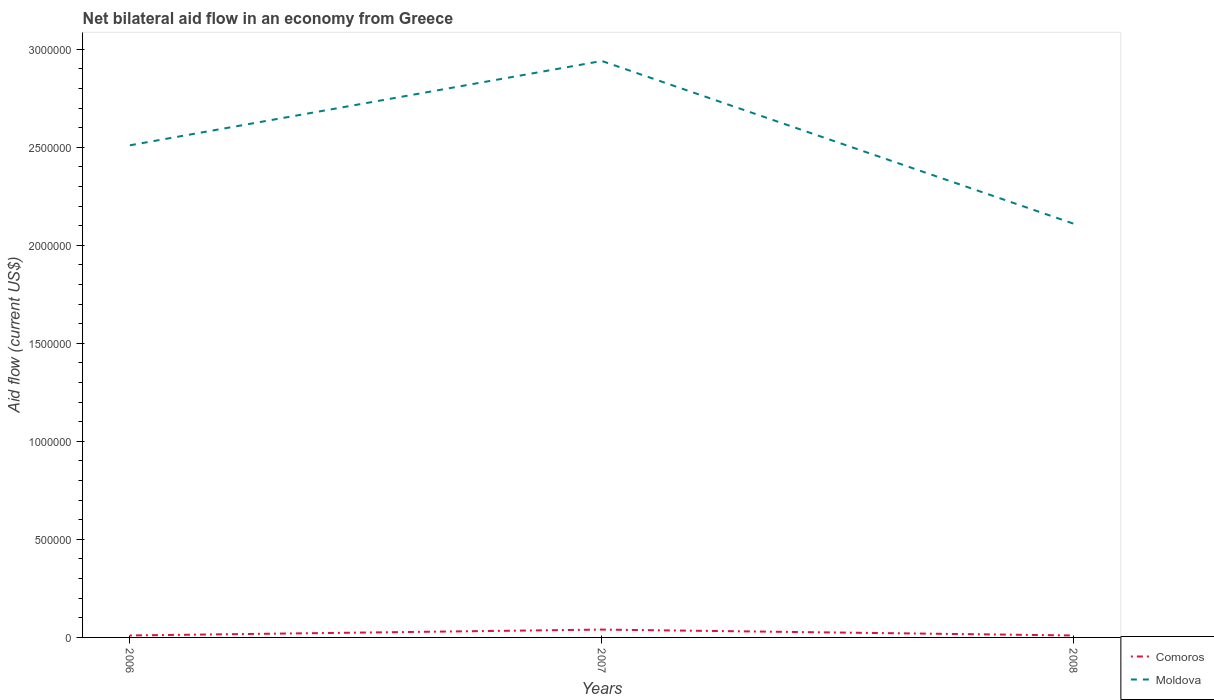How many different coloured lines are there?
Keep it short and to the point. 2. Does the line corresponding to Comoros intersect with the line corresponding to Moldova?
Make the answer very short. No. Is the number of lines equal to the number of legend labels?
Make the answer very short. Yes. Across all years, what is the maximum net bilateral aid flow in Comoros?
Offer a terse response. 10000. What is the total net bilateral aid flow in Moldova in the graph?
Keep it short and to the point. 4.00e+05. What is the difference between the highest and the second highest net bilateral aid flow in Moldova?
Ensure brevity in your answer.  8.30e+05. How many lines are there?
Provide a short and direct response. 2. How many years are there in the graph?
Give a very brief answer. 3. What is the difference between two consecutive major ticks on the Y-axis?
Offer a terse response. 5.00e+05. Does the graph contain grids?
Provide a succinct answer. No. What is the title of the graph?
Provide a short and direct response. Net bilateral aid flow in an economy from Greece. Does "Spain" appear as one of the legend labels in the graph?
Keep it short and to the point. No. What is the label or title of the Y-axis?
Your answer should be compact. Aid flow (current US$). What is the Aid flow (current US$) of Moldova in 2006?
Ensure brevity in your answer.  2.51e+06. What is the Aid flow (current US$) in Moldova in 2007?
Ensure brevity in your answer.  2.94e+06. What is the Aid flow (current US$) of Moldova in 2008?
Your answer should be very brief. 2.11e+06. Across all years, what is the maximum Aid flow (current US$) in Comoros?
Make the answer very short. 4.00e+04. Across all years, what is the maximum Aid flow (current US$) in Moldova?
Offer a terse response. 2.94e+06. Across all years, what is the minimum Aid flow (current US$) in Moldova?
Offer a terse response. 2.11e+06. What is the total Aid flow (current US$) of Comoros in the graph?
Keep it short and to the point. 6.00e+04. What is the total Aid flow (current US$) of Moldova in the graph?
Make the answer very short. 7.56e+06. What is the difference between the Aid flow (current US$) in Comoros in 2006 and that in 2007?
Provide a short and direct response. -3.00e+04. What is the difference between the Aid flow (current US$) in Moldova in 2006 and that in 2007?
Keep it short and to the point. -4.30e+05. What is the difference between the Aid flow (current US$) in Comoros in 2006 and that in 2008?
Your answer should be compact. 0. What is the difference between the Aid flow (current US$) in Moldova in 2006 and that in 2008?
Provide a succinct answer. 4.00e+05. What is the difference between the Aid flow (current US$) of Moldova in 2007 and that in 2008?
Give a very brief answer. 8.30e+05. What is the difference between the Aid flow (current US$) of Comoros in 2006 and the Aid flow (current US$) of Moldova in 2007?
Your answer should be compact. -2.93e+06. What is the difference between the Aid flow (current US$) in Comoros in 2006 and the Aid flow (current US$) in Moldova in 2008?
Give a very brief answer. -2.10e+06. What is the difference between the Aid flow (current US$) of Comoros in 2007 and the Aid flow (current US$) of Moldova in 2008?
Your response must be concise. -2.07e+06. What is the average Aid flow (current US$) of Comoros per year?
Make the answer very short. 2.00e+04. What is the average Aid flow (current US$) of Moldova per year?
Provide a short and direct response. 2.52e+06. In the year 2006, what is the difference between the Aid flow (current US$) in Comoros and Aid flow (current US$) in Moldova?
Your answer should be very brief. -2.50e+06. In the year 2007, what is the difference between the Aid flow (current US$) of Comoros and Aid flow (current US$) of Moldova?
Your answer should be compact. -2.90e+06. In the year 2008, what is the difference between the Aid flow (current US$) of Comoros and Aid flow (current US$) of Moldova?
Keep it short and to the point. -2.10e+06. What is the ratio of the Aid flow (current US$) in Moldova in 2006 to that in 2007?
Provide a short and direct response. 0.85. What is the ratio of the Aid flow (current US$) in Comoros in 2006 to that in 2008?
Ensure brevity in your answer.  1. What is the ratio of the Aid flow (current US$) in Moldova in 2006 to that in 2008?
Make the answer very short. 1.19. What is the ratio of the Aid flow (current US$) in Comoros in 2007 to that in 2008?
Give a very brief answer. 4. What is the ratio of the Aid flow (current US$) in Moldova in 2007 to that in 2008?
Provide a short and direct response. 1.39. What is the difference between the highest and the second highest Aid flow (current US$) in Moldova?
Ensure brevity in your answer.  4.30e+05. What is the difference between the highest and the lowest Aid flow (current US$) of Comoros?
Offer a very short reply. 3.00e+04. What is the difference between the highest and the lowest Aid flow (current US$) of Moldova?
Your response must be concise. 8.30e+05. 